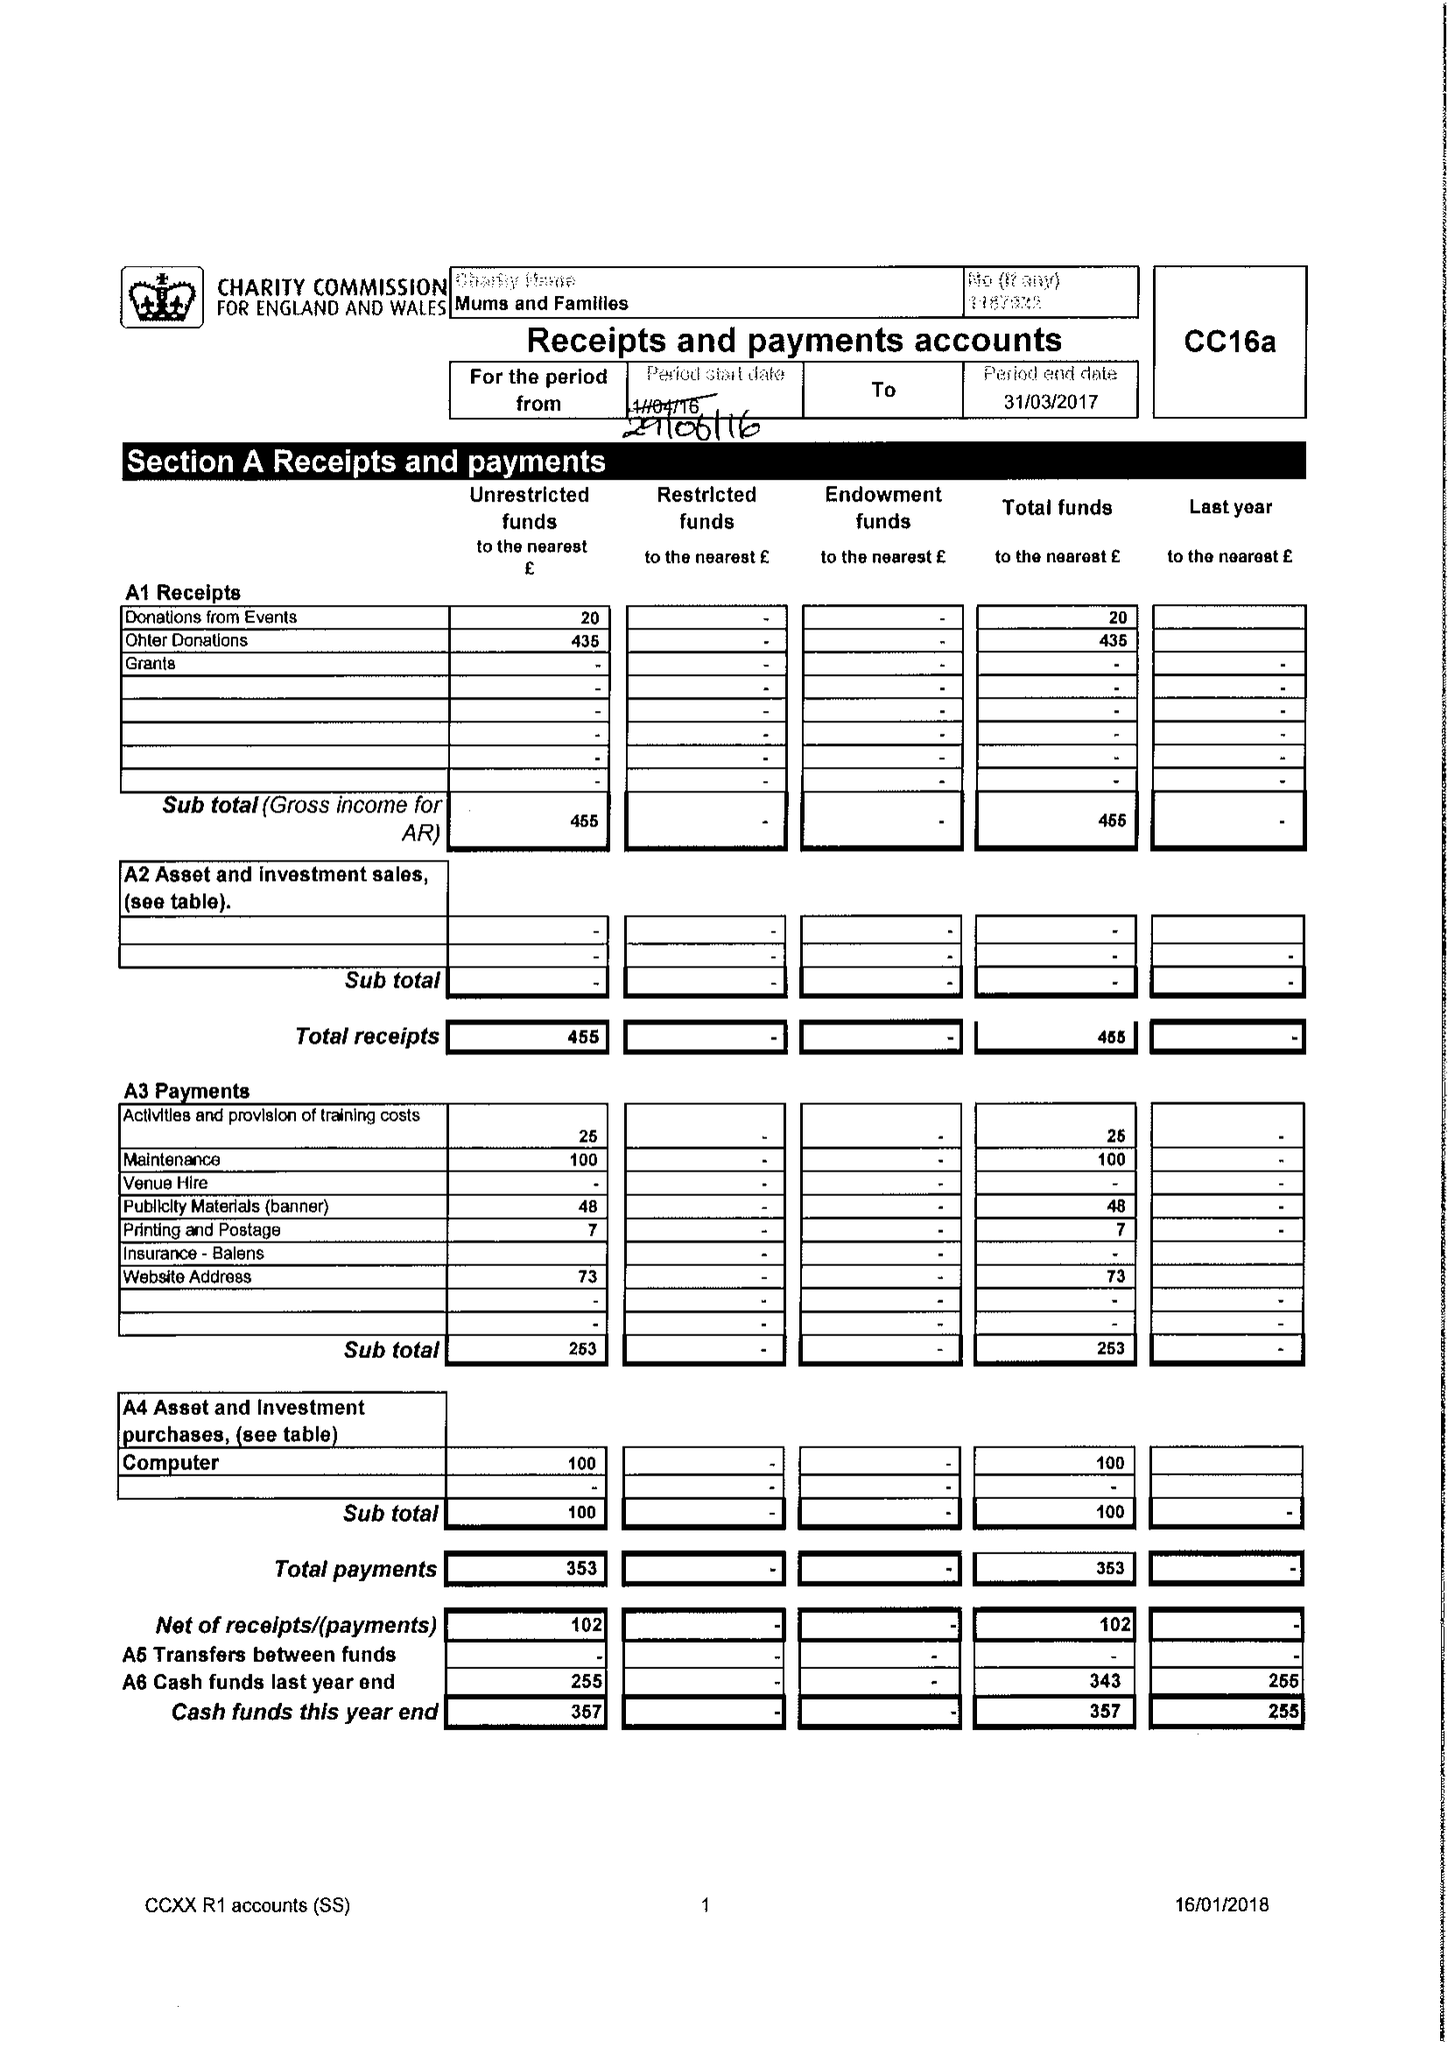What is the value for the address__street_line?
Answer the question using a single word or phrase. 182 WAKE GREEN ROAD 